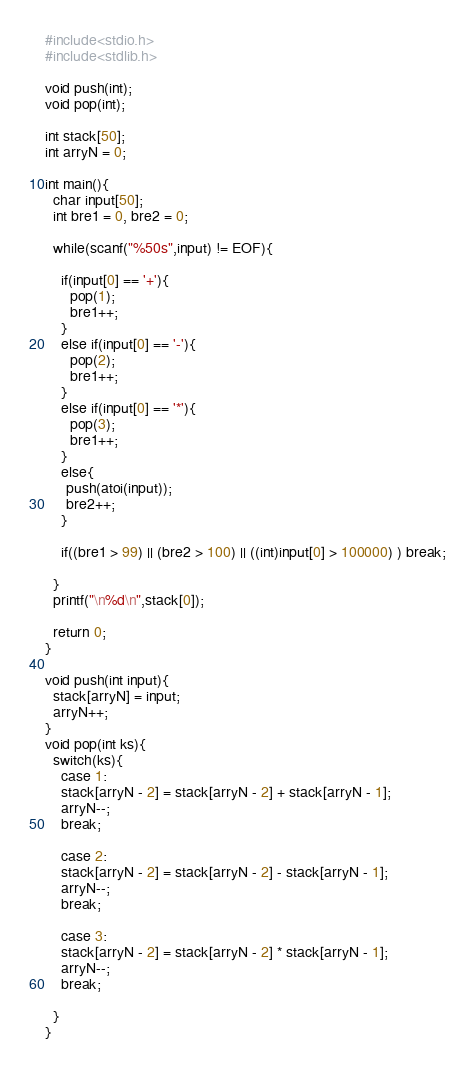Convert code to text. <code><loc_0><loc_0><loc_500><loc_500><_C_>#include<stdio.h>
#include<stdlib.h>

void push(int);
void pop(int);

int stack[50];
int arryN = 0;

int main(){
  char input[50];
  int bre1 = 0, bre2 = 0;

  while(scanf("%50s",input) != EOF){

    if(input[0] == '+'){
      pop(1);
      bre1++;
    }
    else if(input[0] == '-'){
      pop(2);
      bre1++;
    }
    else if(input[0] == '*'){
      pop(3);
      bre1++;
    }
    else{
     push(atoi(input));
     bre2++;
    }

    if((bre1 > 99) || (bre2 > 100) || ((int)input[0] > 100000) ) break;

  }
  printf("\n%d\n",stack[0]);

  return 0;
}

void push(int input){
  stack[arryN] = input;
  arryN++;
}
void pop(int ks){
  switch(ks){
    case 1:
    stack[arryN - 2] = stack[arryN - 2] + stack[arryN - 1];
    arryN--;
    break;

    case 2:
    stack[arryN - 2] = stack[arryN - 2] - stack[arryN - 1];
    arryN--;
    break;

    case 3:
    stack[arryN - 2] = stack[arryN - 2] * stack[arryN - 1];
    arryN--;
    break;

  }
}

</code> 